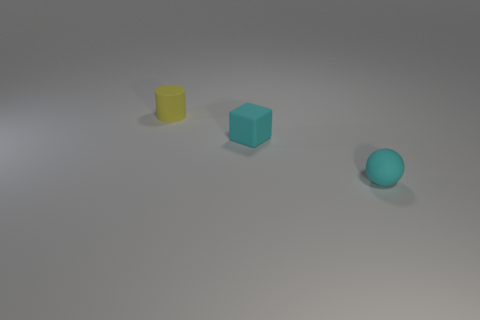How many small balls are on the right side of the rubber ball?
Your answer should be very brief. 0. Is there a cyan matte ball of the same size as the yellow cylinder?
Offer a terse response. Yes. There is a small cyan matte object that is left of the cyan matte sphere; does it have the same shape as the tiny yellow rubber thing?
Offer a very short reply. No. The tiny matte block has what color?
Provide a succinct answer. Cyan. There is a tiny object that is the same color as the sphere; what is its shape?
Give a very brief answer. Cube. Are any yellow cylinders visible?
Provide a short and direct response. Yes. What size is the yellow thing that is made of the same material as the small block?
Offer a very short reply. Small. What is the shape of the tiny cyan rubber thing that is in front of the cyan rubber cube behind the small cyan object that is in front of the block?
Offer a very short reply. Sphere. Are there an equal number of yellow rubber cylinders that are in front of the yellow cylinder and blocks?
Your response must be concise. No. What is the size of the rubber block that is the same color as the matte ball?
Offer a very short reply. Small. 